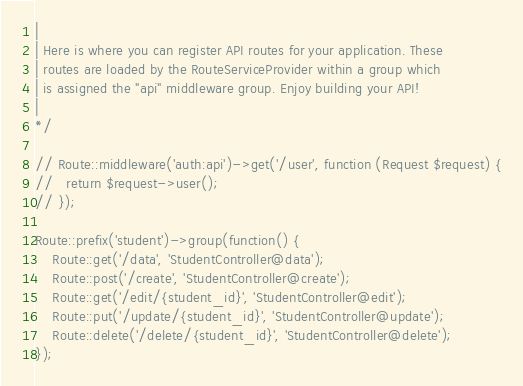Convert code to text. <code><loc_0><loc_0><loc_500><loc_500><_PHP_>|
| Here is where you can register API routes for your application. These
| routes are loaded by the RouteServiceProvider within a group which
| is assigned the "api" middleware group. Enjoy building your API!
|
*/

// Route::middleware('auth:api')->get('/user', function (Request $request) {
//   return $request->user();
// });

Route::prefix('student')->group(function() {
	Route::get('/data', 'StudentController@data');
	Route::post('/create', 'StudentController@create');
	Route::get('/edit/{student_id}', 'StudentController@edit');
	Route::put('/update/{student_id}', 'StudentController@update');
	Route::delete('/delete/{student_id}', 'StudentController@delete');
});</code> 